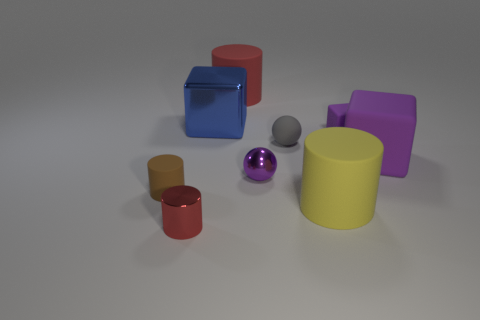Subtract all cylinders. How many objects are left? 5 Subtract all tiny brown cylinders. Subtract all red matte cylinders. How many objects are left? 7 Add 2 tiny brown cylinders. How many tiny brown cylinders are left? 3 Add 6 big blue shiny things. How many big blue shiny things exist? 7 Subtract 0 cyan cylinders. How many objects are left? 9 